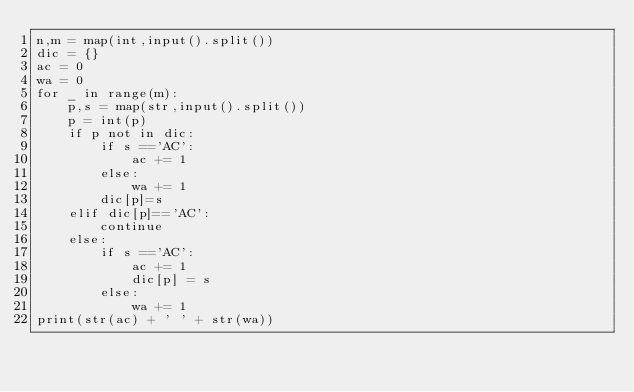Convert code to text. <code><loc_0><loc_0><loc_500><loc_500><_Python_>n,m = map(int,input().split())
dic = {}
ac = 0
wa = 0
for _ in range(m):
    p,s = map(str,input().split())
    p = int(p)
    if p not in dic:
        if s =='AC':
            ac += 1
        else:
            wa += 1
        dic[p]=s
    elif dic[p]=='AC':
        continue
    else:
        if s =='AC':
            ac += 1
            dic[p] = s
        else:
            wa += 1
print(str(ac) + ' ' + str(wa))
</code> 